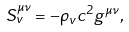Convert formula to latex. <formula><loc_0><loc_0><loc_500><loc_500>S ^ { \mu \nu } _ { v } = - \rho _ { v } c ^ { 2 } g ^ { \mu \nu } ,</formula> 